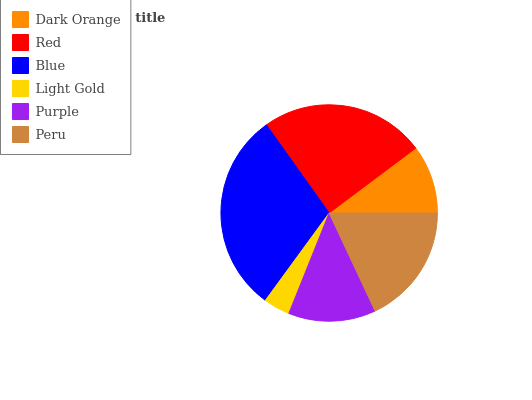Is Light Gold the minimum?
Answer yes or no. Yes. Is Blue the maximum?
Answer yes or no. Yes. Is Red the minimum?
Answer yes or no. No. Is Red the maximum?
Answer yes or no. No. Is Red greater than Dark Orange?
Answer yes or no. Yes. Is Dark Orange less than Red?
Answer yes or no. Yes. Is Dark Orange greater than Red?
Answer yes or no. No. Is Red less than Dark Orange?
Answer yes or no. No. Is Peru the high median?
Answer yes or no. Yes. Is Purple the low median?
Answer yes or no. Yes. Is Red the high median?
Answer yes or no. No. Is Peru the low median?
Answer yes or no. No. 